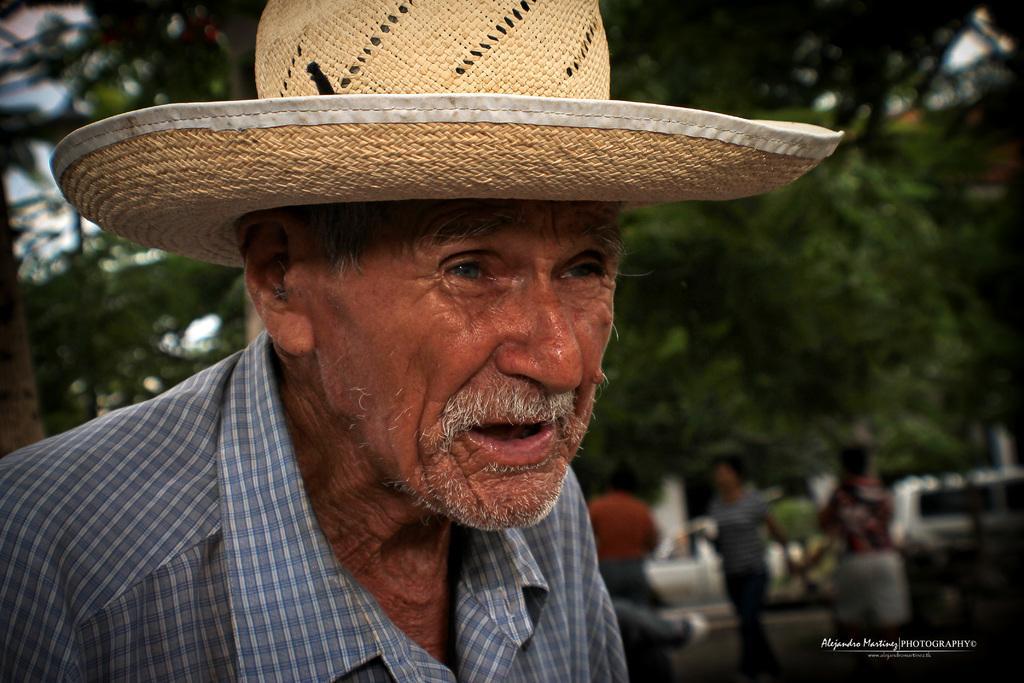Please provide a concise description of this image. In the foreground of the picture there is an old man wearing a hat. The background is blurred. In the background there are people, cars and trees. 